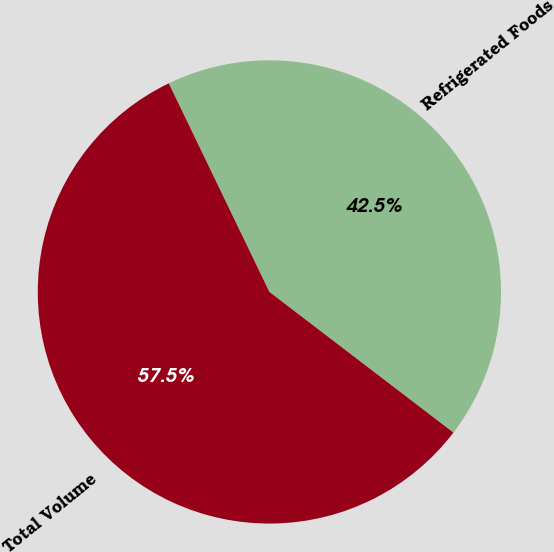Convert chart to OTSL. <chart><loc_0><loc_0><loc_500><loc_500><pie_chart><fcel>Refrigerated Foods<fcel>Total Volume<nl><fcel>42.54%<fcel>57.46%<nl></chart> 